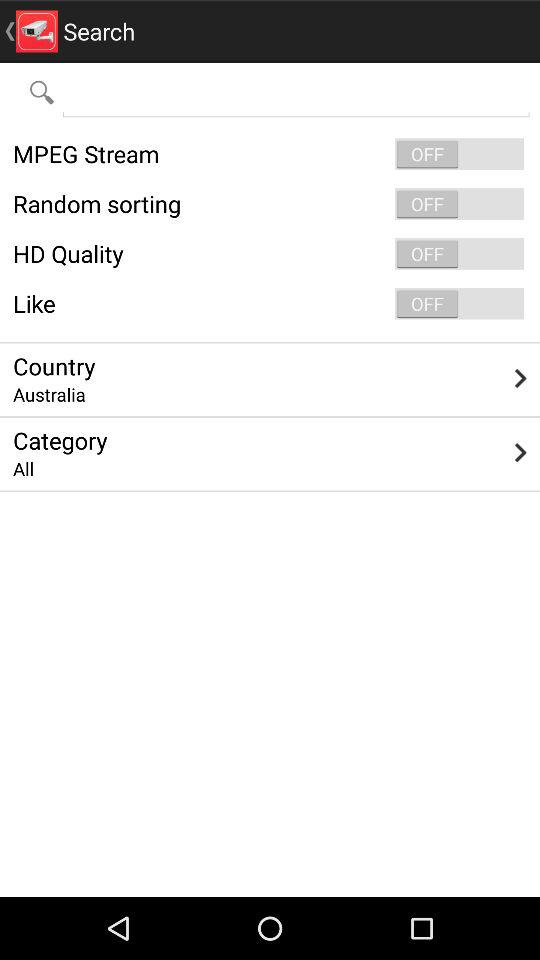What is the current status of HD quality? The status is off. 